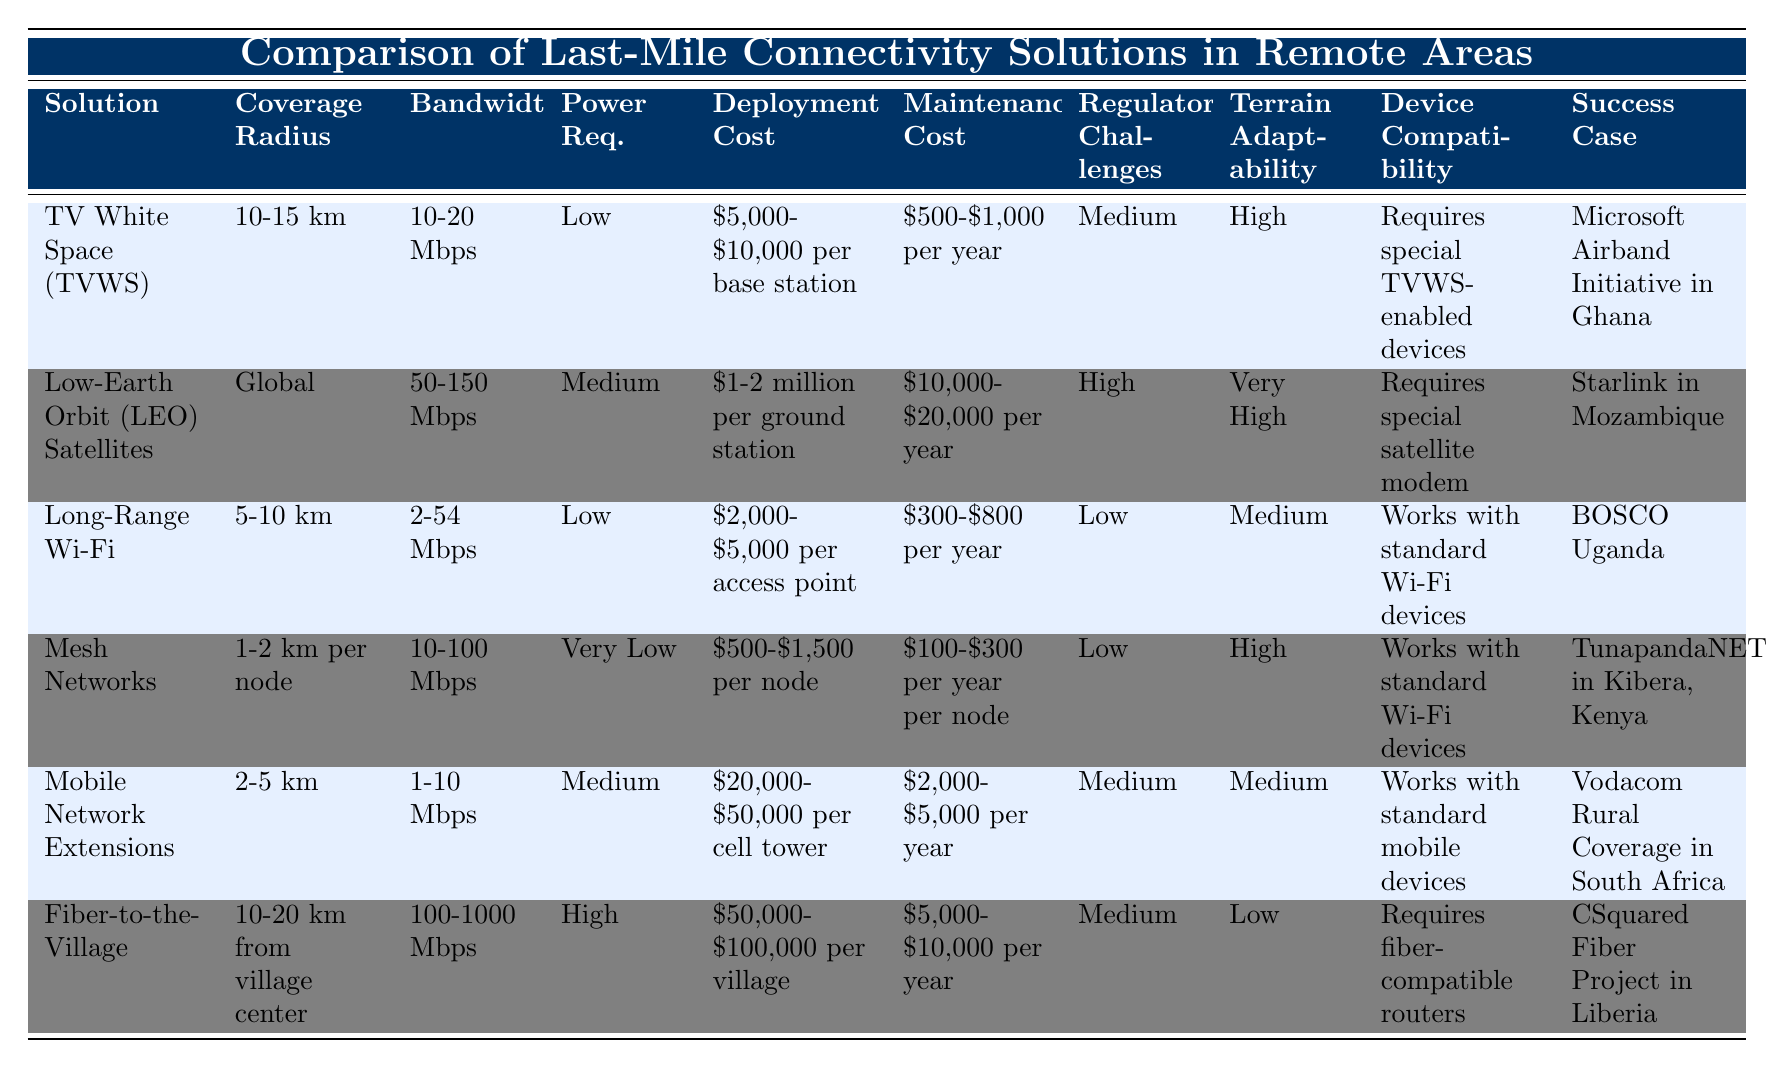What is the coverage radius of Fiber-to-the-Village? The table specifies that the coverage radius for Fiber-to-the-Village is "10-20 km from village center."
Answer: 10-20 km from village center Which solution has the lowest deployment cost? Looking at the deployment costs listed, Mesh Networks have the lowest cost range of "$500-$1,500 per node."
Answer: Mesh Networks What is the average maintenance cost of Mobile Network Extensions and Fiber-to-the-Village solutions? The annual maintenance cost for Mobile Network Extensions is "$2,000-$5,000," and for Fiber-to-the-Village it is "$5,000-$10,000." The average for Mobile Network Extensions is (2000 + 5000) / 2 = 3,500; for Fiber-to-the-Village it is (5000 + 10000) / 2 = 7,500. So, the overall average is (3,500 + 7,500) / 2 = 5,500.
Answer: 5,500 Is the bandwidth of Long-Range Wi-Fi greater than the bandwidth of TV White Space? Long-Range Wi-Fi has a bandwidth range of "2-54 Mbps" which is greater than the bandwidth of TV White Space, which is "10-20 Mbps." Therefore, the statement is true.
Answer: Yes Which last-mile connectivity solution has very high terrain adaptability? The terrain adaptability is classified as "Very High" for Low-Earth Orbit (LEO) Satellites while other solutions have lower adaptability levels.
Answer: Low-Earth Orbit (LEO) Satellites What is the difference in bandwidth between Fiber-to-the-Village and LEO Satellites? Fiber-to-the-Village has a bandwidth range of "100-1000 Mbps," and LEO Satellites have a bandwidth range of "50-150 Mbps." The difference in the maximum is 1000 - 150 = 850 Mbps, while the minimum is 100 - 50 = 50 Mbps. Thus, the difference in maximum bandwidth is 850 Mbps.
Answer: 850 Mbps Does Mobile Network Extensions require special mobile devices? According to the device compatibility column, Mobile Network Extensions state that it "Works with standard mobile devices," hence it does not require special devices.
Answer: No What is the total cost range for deploying TV White Space versus Long-Range Wi-Fi? The deployment cost for TV White Space ranges from "$5,000-$10,000 per base station," and for Long-Range Wi-Fi ranges from "$2,000-$5,000 per access point." To find the total range, we sum the lower bounds (5000 + 2000 = 7000) and the upper bounds (10000 + 5000 = 15000). Therefore, the total range for deployment costs is "$7,000-$15,000."
Answer: $7,000-$15,000 